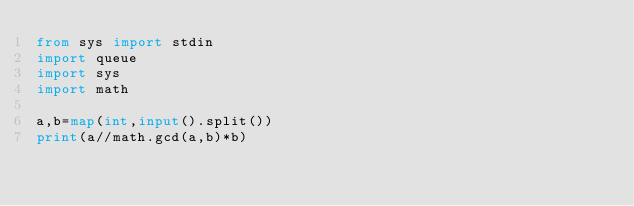Convert code to text. <code><loc_0><loc_0><loc_500><loc_500><_Python_>from sys import stdin
import queue
import sys
import math

a,b=map(int,input().split())
print(a//math.gcd(a,b)*b)</code> 